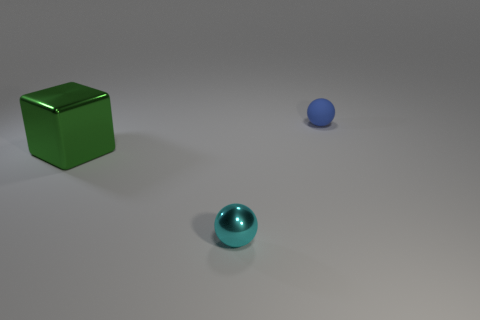Add 2 big red cubes. How many objects exist? 5 Subtract all balls. How many objects are left? 1 Subtract 0 red cylinders. How many objects are left? 3 Subtract all small blue metal spheres. Subtract all rubber things. How many objects are left? 2 Add 2 small objects. How many small objects are left? 4 Add 3 big metal blocks. How many big metal blocks exist? 4 